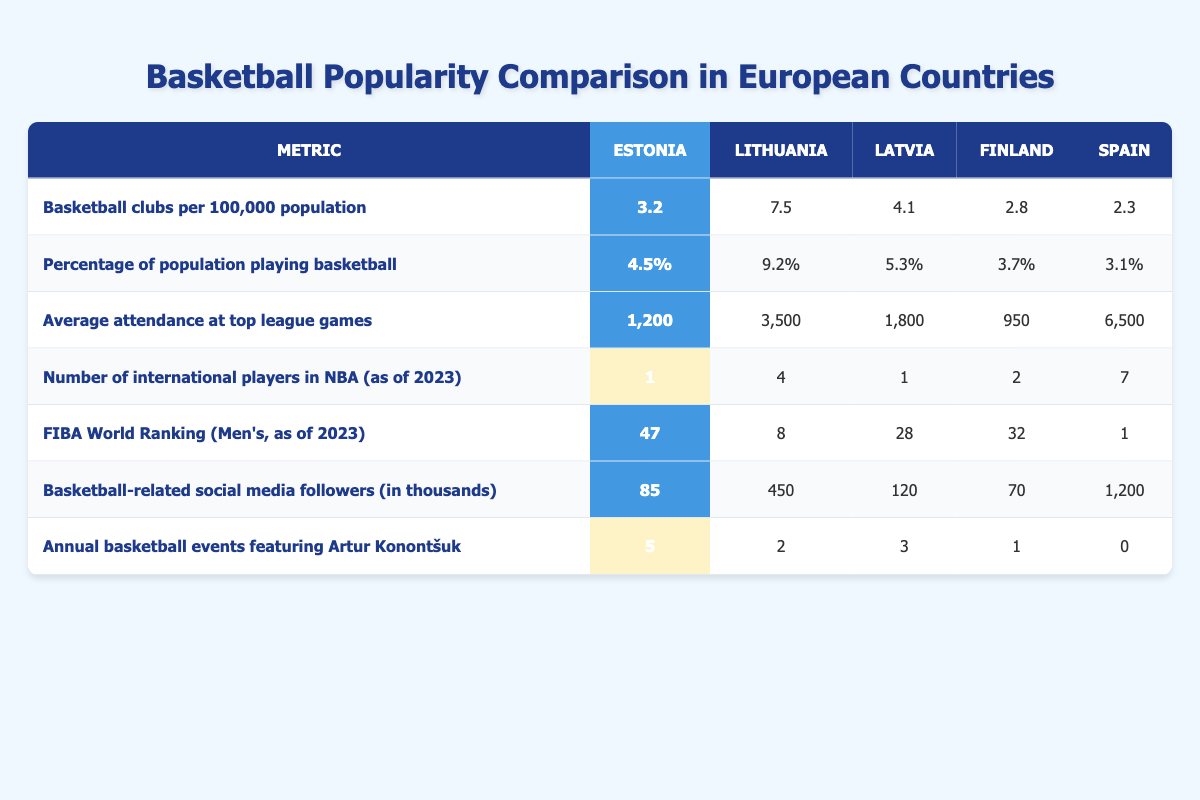What is the average attendance at top league games in Estonia? The table shows that the average attendance at top league games in Estonia is 1,200. Since there is only one value presented for Estonia, this is the answer.
Answer: 1,200 Which country has the highest number of basketball clubs per 100,000 population? The table indicates Lithuania has the highest number of basketball clubs per 100,000 population, with a value of 7.5, compared to Estonia (3.2), Latvia (4.1), Finland (2.8), and Spain (2.3).
Answer: Lithuania How many more basketball-related social media followers does Spain have compared to Estonia? Spain has 1,200 followers while Estonia has 85. The difference is 1,200 - 85 = 1,115 followers, indicating Spain has significantly more.
Answer: 1,115 Is Estonia ranked higher than Latvia in the FIBA World Ranking? The table shows Estonia is ranked 47th while Latvia is ranked 28th. Since 47 is greater than 28, Estonia is ranked lower than Latvia.
Answer: No What is the total number of annual basketball events featuring Artur Konontšuk for Estonia and Latvia combined? Estonia has 5 events and Latvia has 3 events. Adding these together gives 5 + 3 = 8 events in total for Estonia and Latvia.
Answer: 8 Which country has the least percentage of its population playing basketball? Looking at the table, Spain has the least percentage of its population playing basketball at 3.1%, less than Estonia (4.5%), Lithuania (9.2%), Latvia (5.3%), and Finland (3.7%).
Answer: Spain How does the average attendance at top league games in Estonia compare to that of Lithuania? Estonia's attendance is 1,200, while Lithuania's is 3,500. The difference is 3,500 - 1,200 = 2,300, showing that Lithuania has significantly higher attendance.
Answer: 2,300 Which country has the highest number of international players in the NBA as of 2023? According to the table, Spain leads with 7 international players in the NBA, outperforming Estonia (1), Lithuania (4), Latvia (1), and Finland (2).
Answer: Spain What is the average (mean) number of basketball clubs per 100,000 population across all five countries? To find the average, sum the values: 3.2 (Estonia) + 7.5 (Lithuania) + 4.1 (Latvia) + 2.8 (Finland) + 2.3 (Spain) = 19.9. Then divide by 5 (the number of countries): 19.9 / 5 = 3.98.
Answer: 3.98 